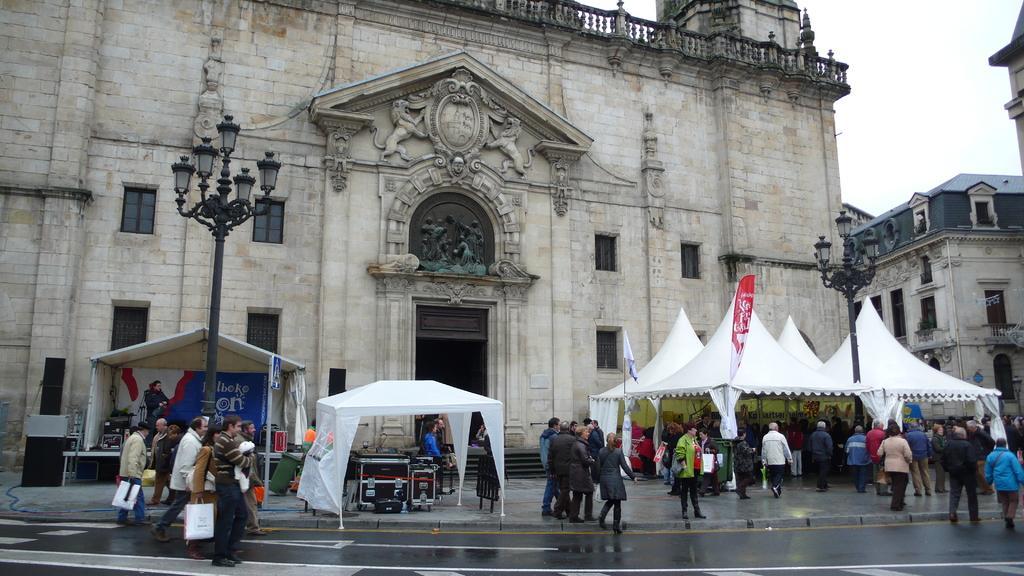Can you describe this image briefly? There is a group of persons are walking on the road as we can see at the bottom of this image. There are some tents on the left side of this image, and right side of this image as well. There is a monument in the background, and there is a sky at the top of this image. 